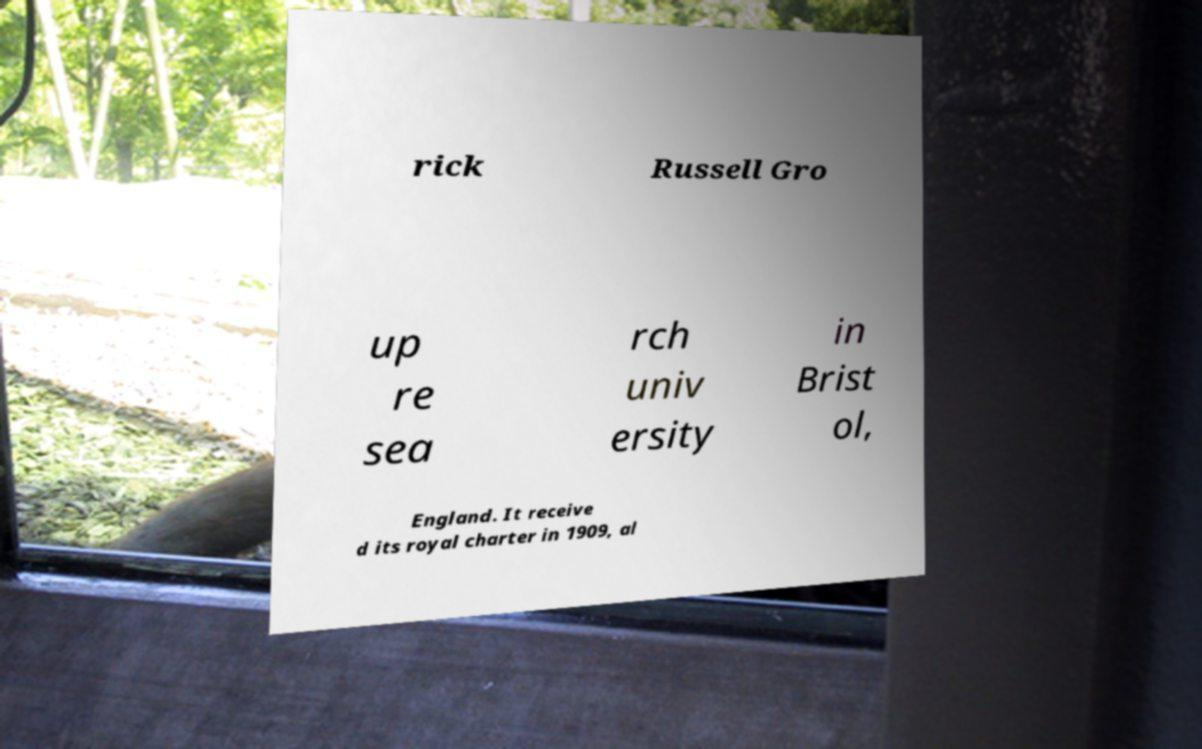There's text embedded in this image that I need extracted. Can you transcribe it verbatim? rick Russell Gro up re sea rch univ ersity in Brist ol, England. It receive d its royal charter in 1909, al 